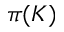Convert formula to latex. <formula><loc_0><loc_0><loc_500><loc_500>\pi ( K )</formula> 